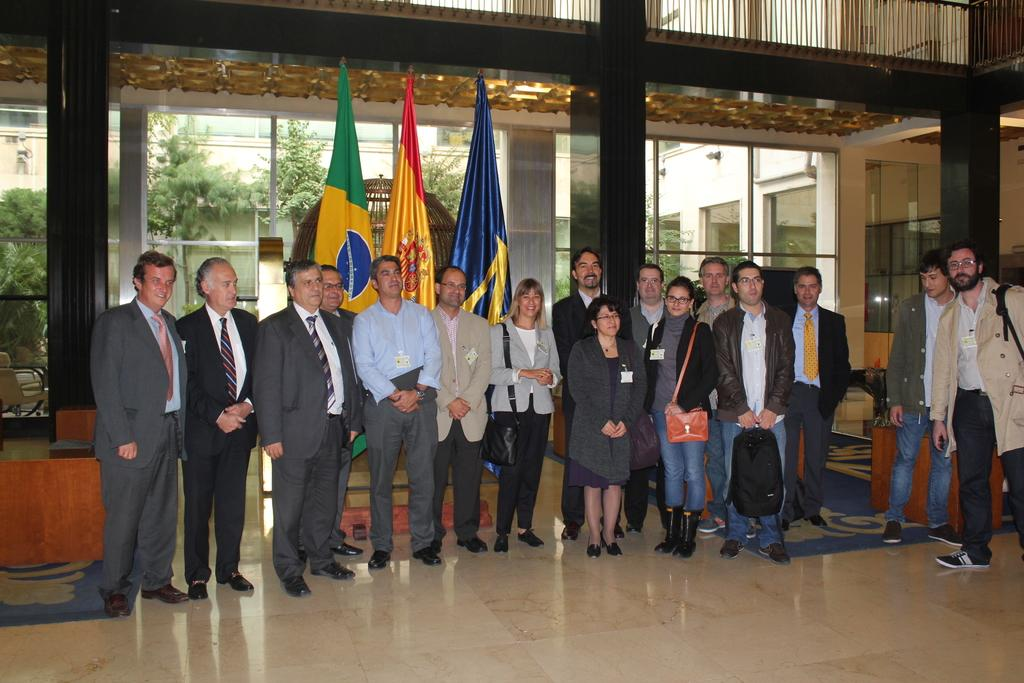How many people are in the group visible in the image? There is a group of people in the image, but the exact number cannot be determined from the provided facts. What is located behind the group of people? There are flags visible behind the group of people. What can be seen in the background of the image? There are buildings, trees, and glasses in the background of the image. What type of lighting is present in the image? There are lights in the image, but their specific type or function cannot be determined from the provided facts. What is the weight of the division between the trees and buildings in the image? There is no division between the trees and buildings mentioned in the image, and therefore no weight can be assigned to it. 